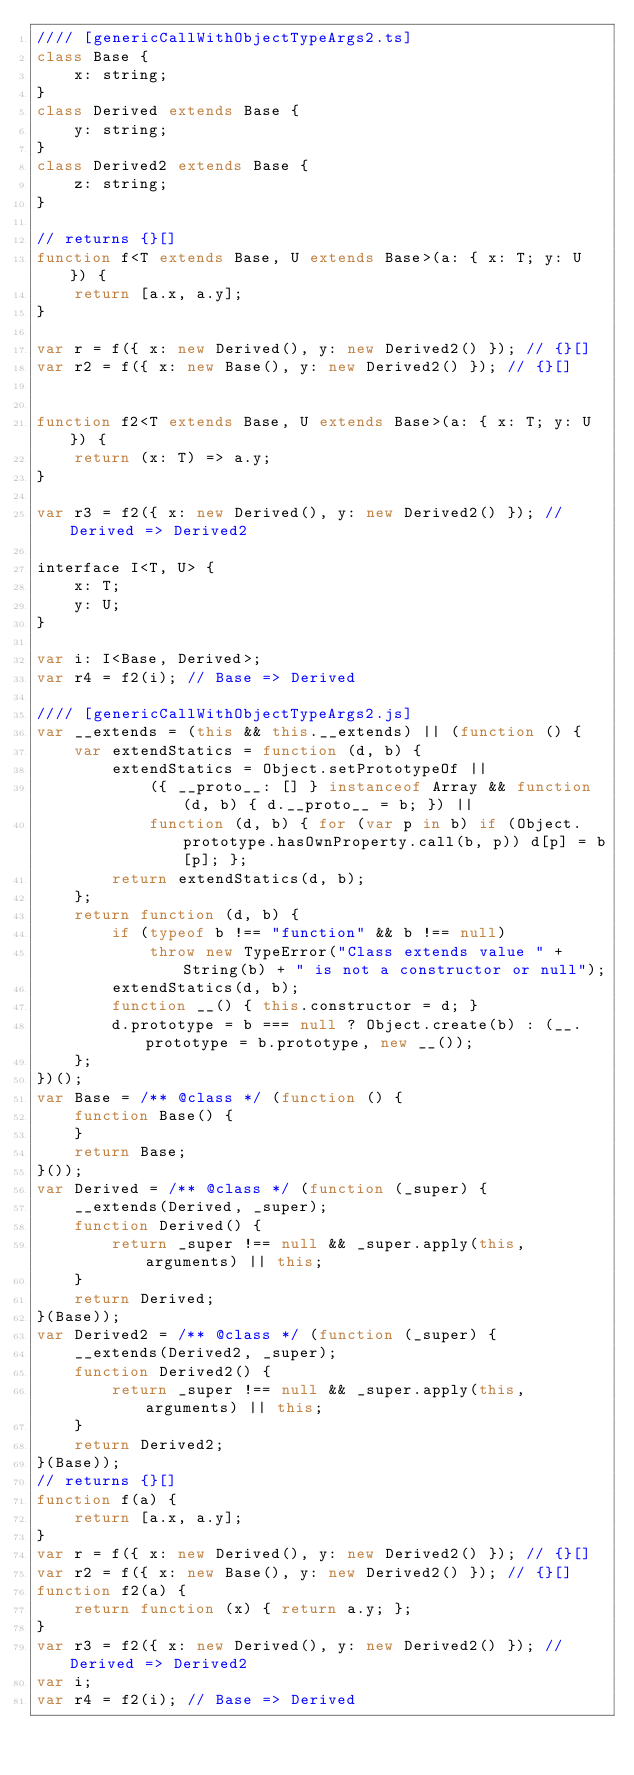<code> <loc_0><loc_0><loc_500><loc_500><_JavaScript_>//// [genericCallWithObjectTypeArgs2.ts]
class Base {
    x: string;
}
class Derived extends Base {
    y: string;
}
class Derived2 extends Base {
    z: string;
}

// returns {}[]
function f<T extends Base, U extends Base>(a: { x: T; y: U }) {
    return [a.x, a.y];
}

var r = f({ x: new Derived(), y: new Derived2() }); // {}[]
var r2 = f({ x: new Base(), y: new Derived2() }); // {}[]


function f2<T extends Base, U extends Base>(a: { x: T; y: U }) {
    return (x: T) => a.y;
}

var r3 = f2({ x: new Derived(), y: new Derived2() }); // Derived => Derived2

interface I<T, U> {
    x: T;
    y: U;
}

var i: I<Base, Derived>;
var r4 = f2(i); // Base => Derived

//// [genericCallWithObjectTypeArgs2.js]
var __extends = (this && this.__extends) || (function () {
    var extendStatics = function (d, b) {
        extendStatics = Object.setPrototypeOf ||
            ({ __proto__: [] } instanceof Array && function (d, b) { d.__proto__ = b; }) ||
            function (d, b) { for (var p in b) if (Object.prototype.hasOwnProperty.call(b, p)) d[p] = b[p]; };
        return extendStatics(d, b);
    };
    return function (d, b) {
        if (typeof b !== "function" && b !== null)
            throw new TypeError("Class extends value " + String(b) + " is not a constructor or null");
        extendStatics(d, b);
        function __() { this.constructor = d; }
        d.prototype = b === null ? Object.create(b) : (__.prototype = b.prototype, new __());
    };
})();
var Base = /** @class */ (function () {
    function Base() {
    }
    return Base;
}());
var Derived = /** @class */ (function (_super) {
    __extends(Derived, _super);
    function Derived() {
        return _super !== null && _super.apply(this, arguments) || this;
    }
    return Derived;
}(Base));
var Derived2 = /** @class */ (function (_super) {
    __extends(Derived2, _super);
    function Derived2() {
        return _super !== null && _super.apply(this, arguments) || this;
    }
    return Derived2;
}(Base));
// returns {}[]
function f(a) {
    return [a.x, a.y];
}
var r = f({ x: new Derived(), y: new Derived2() }); // {}[]
var r2 = f({ x: new Base(), y: new Derived2() }); // {}[]
function f2(a) {
    return function (x) { return a.y; };
}
var r3 = f2({ x: new Derived(), y: new Derived2() }); // Derived => Derived2
var i;
var r4 = f2(i); // Base => Derived
</code> 